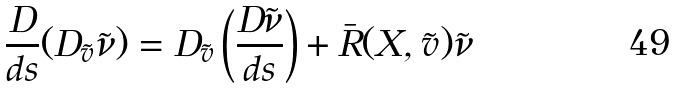<formula> <loc_0><loc_0><loc_500><loc_500>\frac { D } { d s } ( D _ { \tilde { v } } \tilde { \nu } ) = D _ { \tilde { v } } \left ( \frac { D \tilde { \nu } } { d s } \right ) + \bar { R } ( X , \tilde { v } ) \tilde { \nu }</formula> 